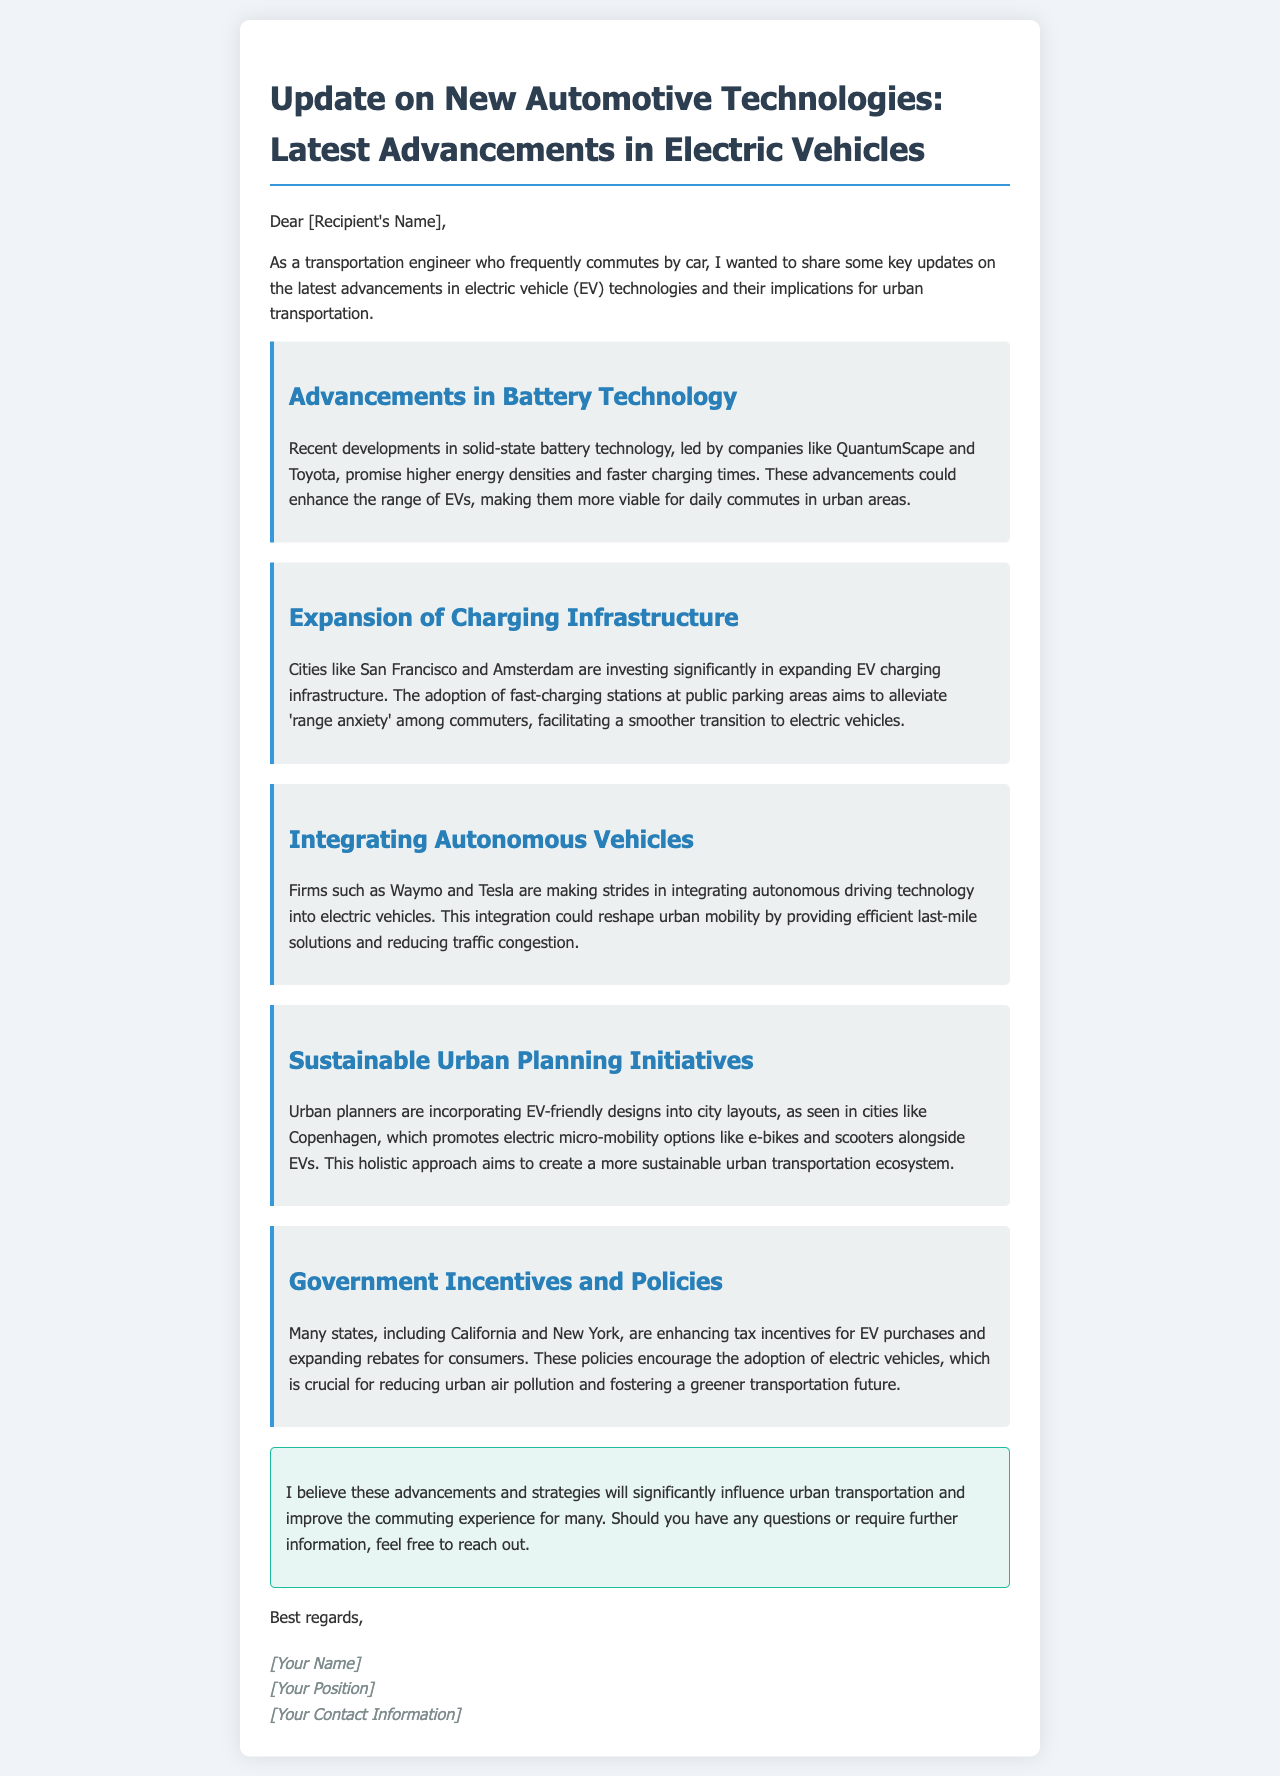What is the focus of the email? The focus of the email is on the latest advancements in electric vehicle technologies and their implications for urban transportation.
Answer: Advancements in electric vehicle technologies Which company is leading in solid-state battery technology? The document mentions QuantumScape as one of the companies leading in solid-state battery technology.
Answer: QuantumScape What cities are investing in EV charging infrastructure? San Francisco and Amsterdam are specifically mentioned as cities investing in EV charging infrastructure.
Answer: San Francisco and Amsterdam What mode of transport is being integrated with electric vehicles? The document states that autonomous driving technology is being integrated with electric vehicles.
Answer: Autonomous driving technology What is the goal of urban planners in promoting EV-friendly designs? The goal is to create a more sustainable urban transportation ecosystem.
Answer: Sustainable urban transportation ecosystem What types of incentives are being enhanced by states like California and New York? The states are enhancing tax incentives for EV purchases.
Answer: Tax incentives for EV purchases 